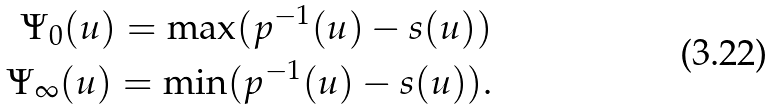Convert formula to latex. <formula><loc_0><loc_0><loc_500><loc_500>\Psi _ { 0 } ( u ) = \max ( p ^ { - 1 } ( u ) - s ( u ) ) \\ \Psi _ { \infty } ( u ) = \min ( p ^ { - 1 } ( u ) - s ( u ) ) .</formula> 